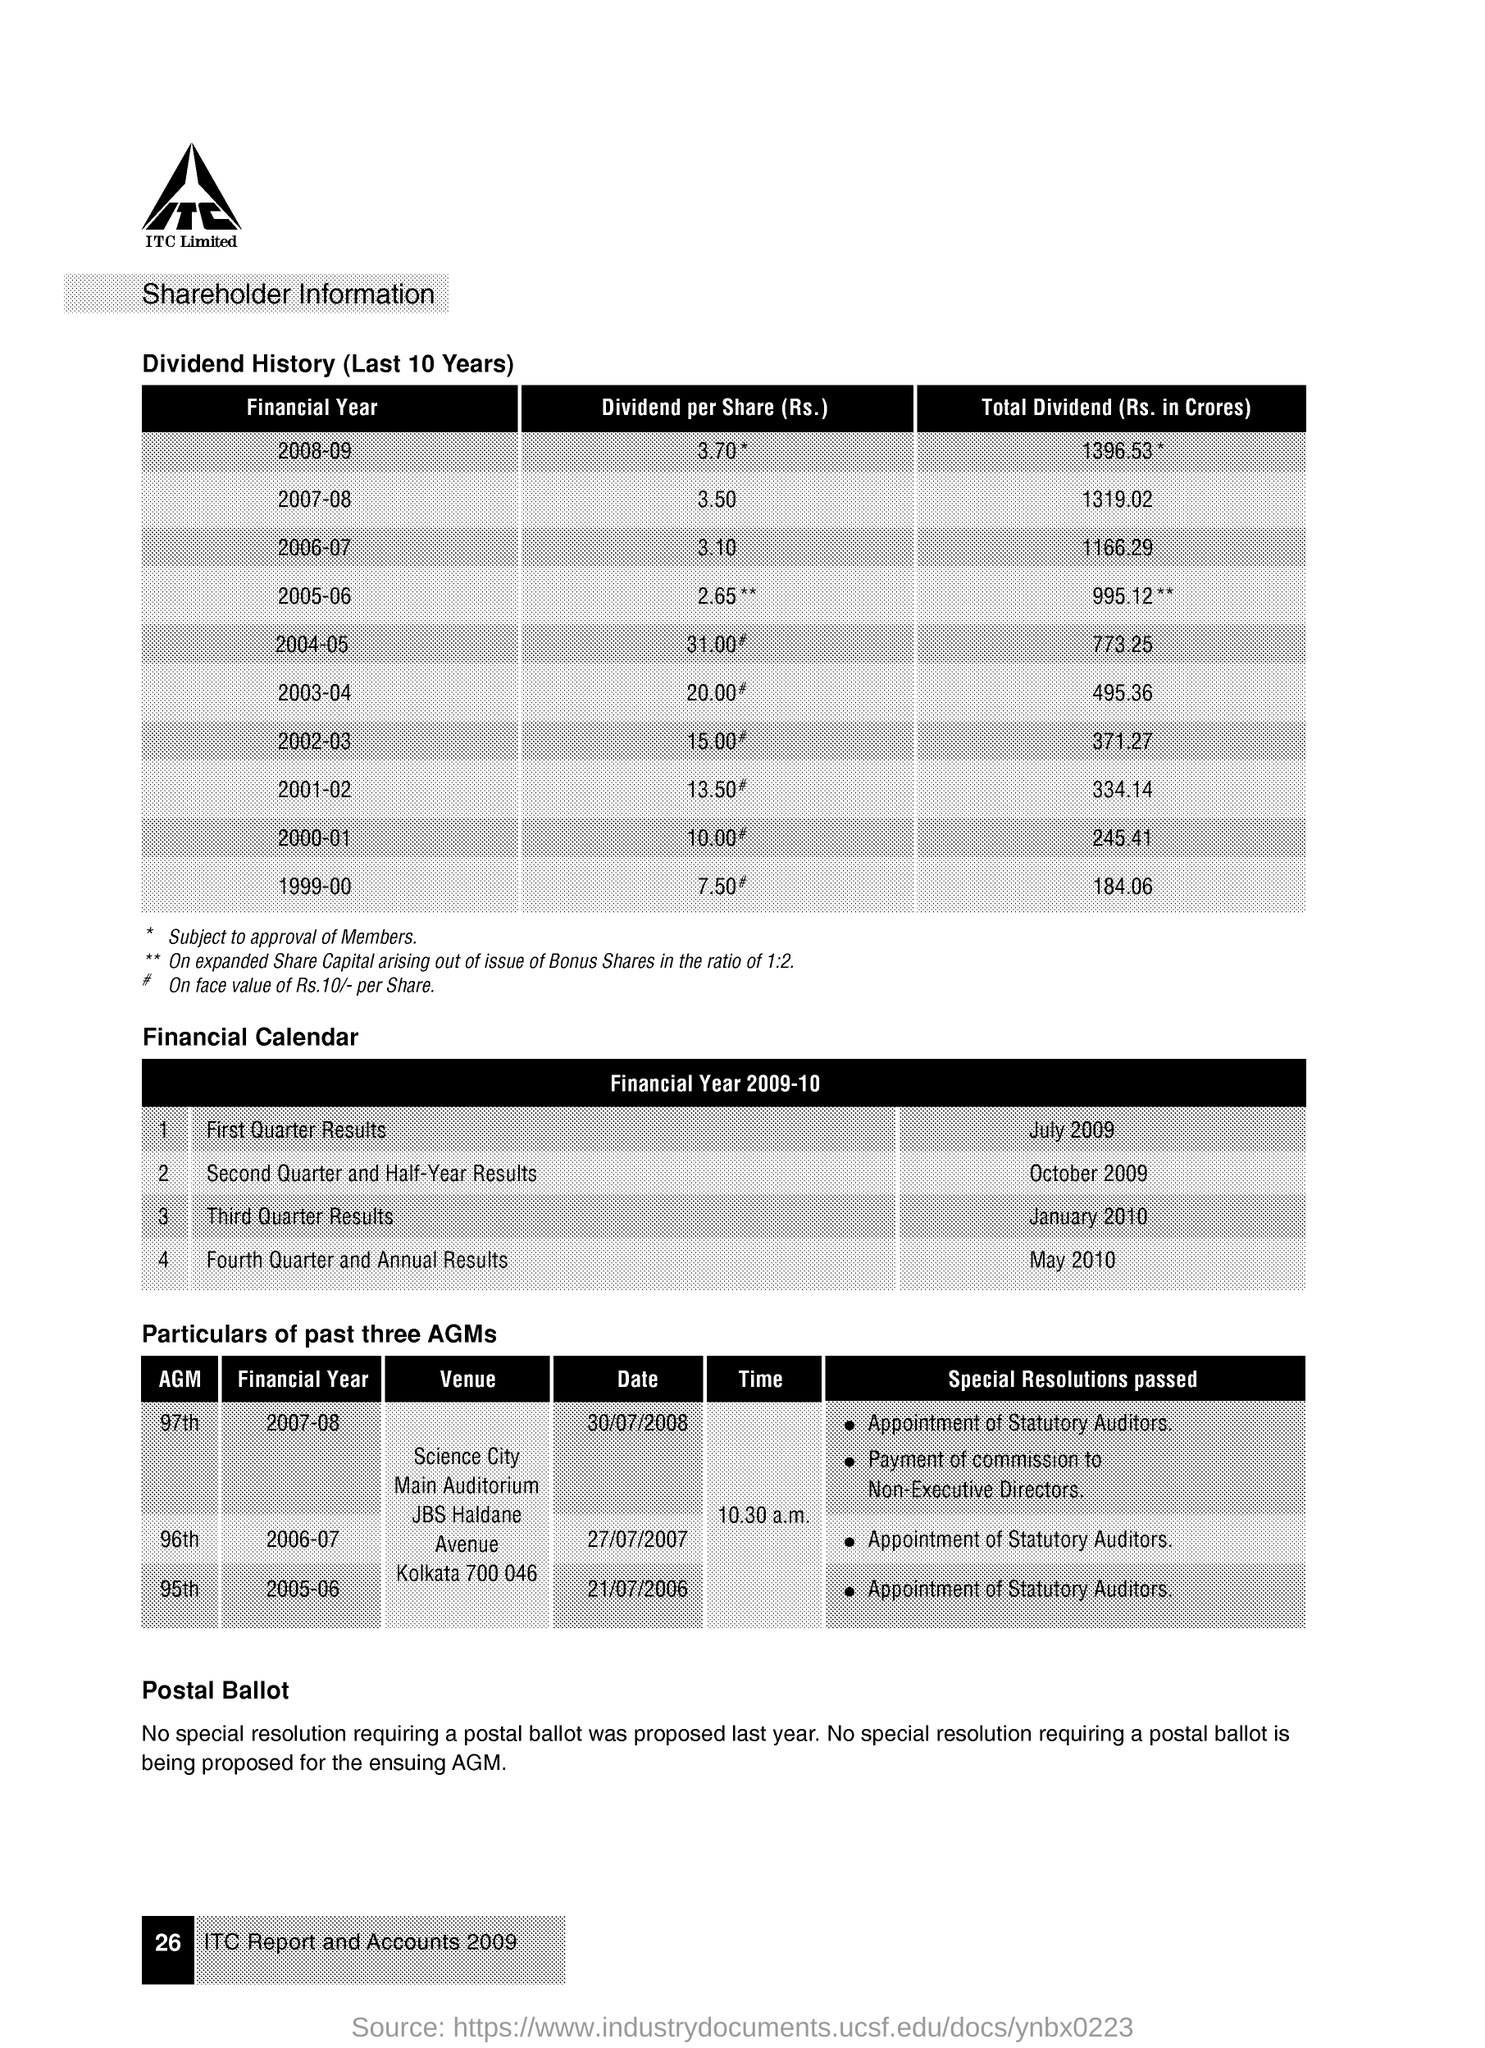in which financial year the 97th AGM was conducted ? The 97th Annual General Meeting (AGM) was conducted in the financial year 2007-08. It took place on July 30th, 2008 at Science City Main Auditorium, and among the key resolutions passed were the appointment of Statutory Auditors and the payment of commission to Non-Executive Directors. 